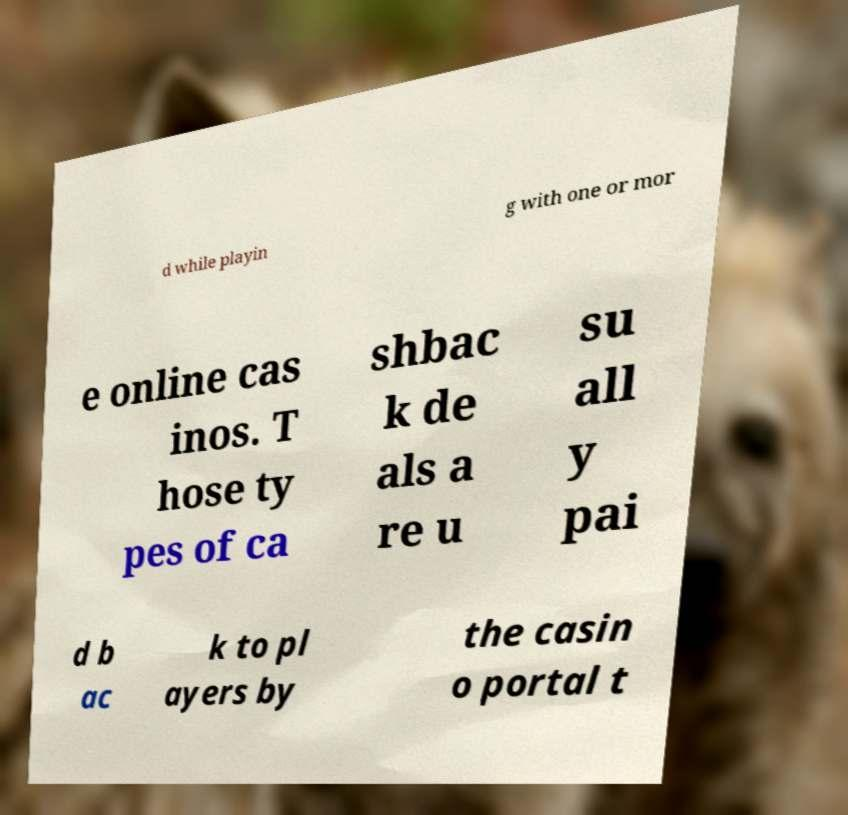I need the written content from this picture converted into text. Can you do that? d while playin g with one or mor e online cas inos. T hose ty pes of ca shbac k de als a re u su all y pai d b ac k to pl ayers by the casin o portal t 